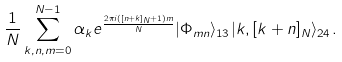Convert formula to latex. <formula><loc_0><loc_0><loc_500><loc_500>\frac { 1 } { N } \sum ^ { N - 1 } _ { k , n , m = 0 } \alpha _ { k } e ^ { \frac { 2 \pi i ( [ n + k ] _ { N } + 1 ) m } { N } } | \Phi _ { m n } \rangle _ { 1 3 } | k , [ k + n ] _ { N } \rangle _ { 2 4 } .</formula> 